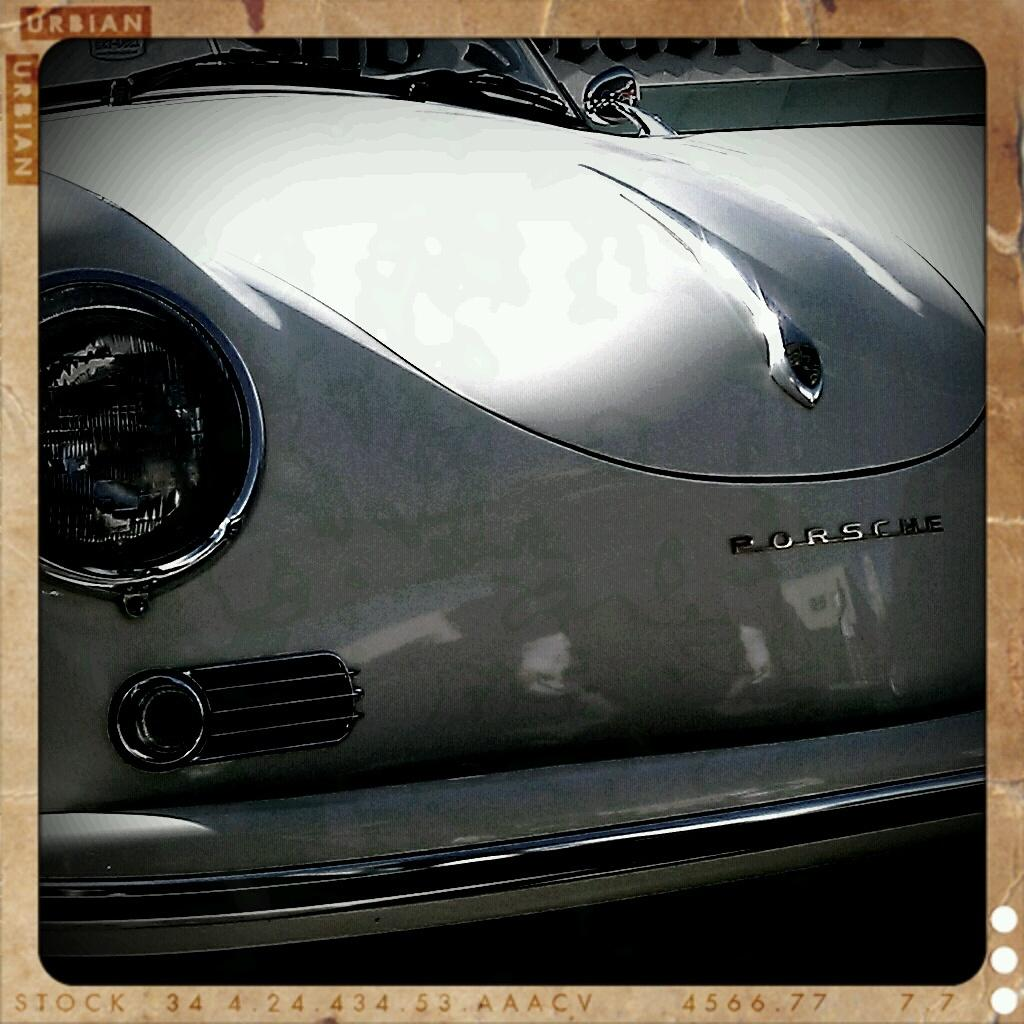What is the main subject of the image? There is a car in the image. Can you describe the car in the image? The provided facts do not give specific details about the car, so we cannot describe it further. What type of cast can be seen on the car's tire in the image? There is no cast present on the car's tire in the image, as the provided facts do not mention any damage or modifications to the car. 